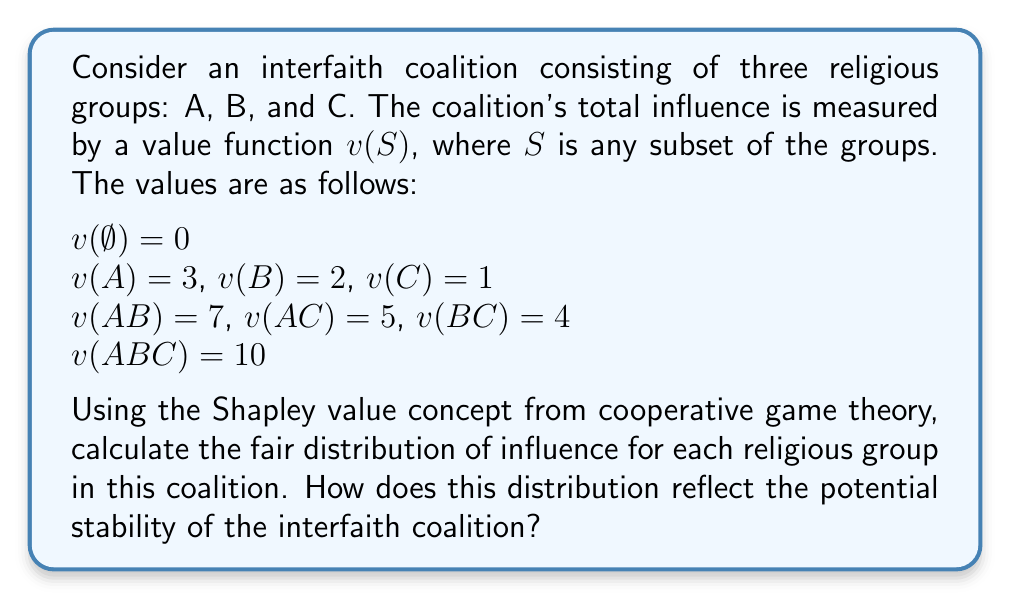Could you help me with this problem? To solve this problem, we need to calculate the Shapley value for each religious group in the coalition. The Shapley value represents a fair allocation of the total coalition value among its members, considering all possible orderings of coalition formation.

The Shapley value for player $i$ is given by the formula:

$$ \phi_i(v) = \sum_{S \subseteq N \setminus \{i\}} \frac{|S|!(n-|S|-1)!}{n!}[v(S \cup \{i\}) - v(S)] $$

Where:
- $N$ is the set of all players
- $n$ is the total number of players
- $S$ is a subset of players not including $i$
- $v$ is the characteristic function of the game

Let's calculate the Shapley value for each group:

1. For group A:
   $\phi_A = \frac{1}{3}[v(A) - v(\emptyset)] + \frac{1}{6}[v(AB) - v(B)] + \frac{1}{6}[v(AC) - v(C)] + \frac{1}{3}[v(ABC) - v(BC)]$
   $\phi_A = \frac{1}{3}(3-0) + \frac{1}{6}(7-2) + \frac{1}{6}(5-1) + \frac{1}{3}(10-4) = 1 + \frac{5}{6} + \frac{2}{3} + 2 = \frac{13}{3}$

2. For group B:
   $\phi_B = \frac{1}{3}[v(B) - v(\emptyset)] + \frac{1}{6}[v(AB) - v(A)] + \frac{1}{6}[v(BC) - v(C)] + \frac{1}{3}[v(ABC) - v(AC)]$
   $\phi_B = \frac{1}{3}(2-0) + \frac{1}{6}(7-3) + \frac{1}{6}(4-1) + \frac{1}{3}(10-5) = \frac{2}{3} + \frac{2}{3} + \frac{1}{2} + \frac{5}{3} = \frac{10}{3}$

3. For group C:
   $\phi_C = \frac{1}{3}[v(C) - v(\emptyset)] + \frac{1}{6}[v(AC) - v(A)] + \frac{1}{6}[v(BC) - v(B)] + \frac{1}{3}[v(ABC) - v(AB)]$
   $\phi_C = \frac{1}{3}(1-0) + \frac{1}{6}(5-3) + \frac{1}{6}(4-2) + \frac{1}{3}(10-7) = \frac{1}{3} + \frac{1}{3} + \frac{1}{3} + 1 = 2$

The Shapley values reflect the potential stability of the interfaith coalition by providing a fair distribution of influence based on each group's marginal contributions. Group A receives the highest share, followed by B and then C, which aligns with their individual and coalition values. This distribution suggests that the coalition is more likely to be stable if the groups accept this allocation of influence, as it takes into account their relative contributions to various subcoalitions.
Answer: The Shapley values for the religious groups are:

Group A: $\frac{13}{3} \approx 4.33$
Group B: $\frac{10}{3} \approx 3.33$
Group C: $2$

This distribution reflects the potential stability of the interfaith coalition by allocating influence fairly based on each group's marginal contributions, with Group A having the most influence, followed by B and then C. 